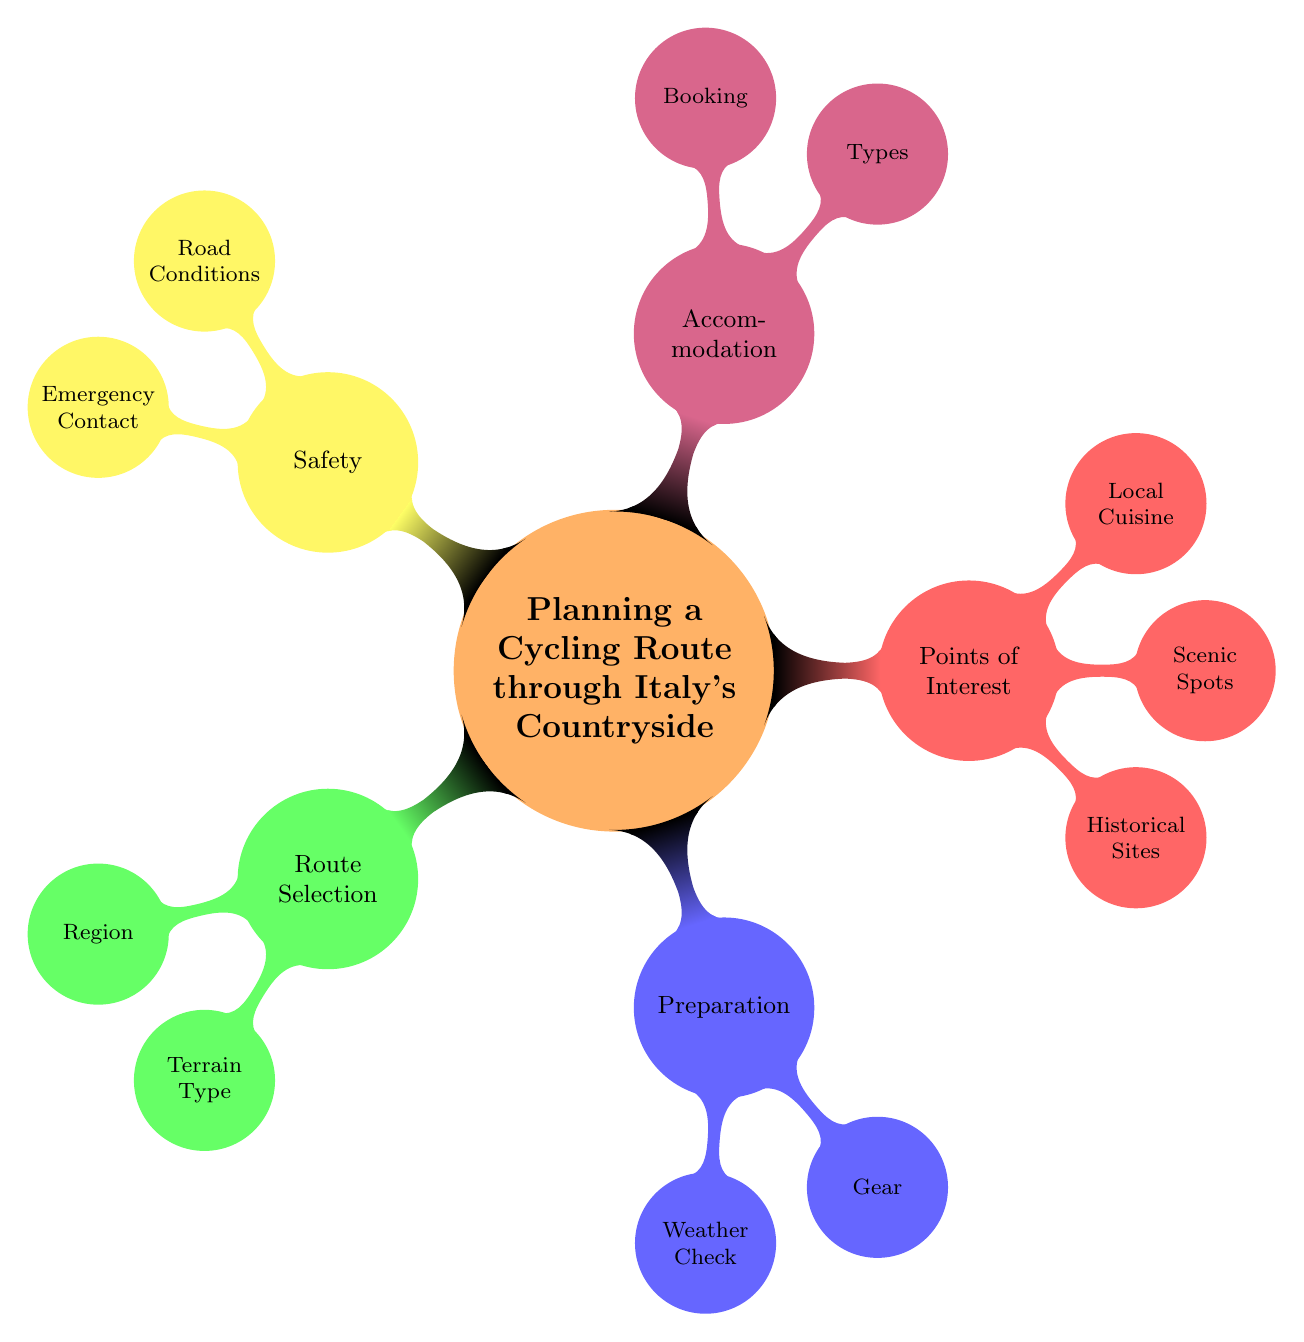What are the two main categories under Route Selection? The diagram lists "Region" and "Terrain Type" as the main categories under Route Selection. These are the child nodes connected to the Route Selection node, indicating the aspects to consider when selecting a route.
Answer: Region, Terrain Type How many points of interest categories are there? The Points of Interest section has three categories: Historical Sites, Scenic Spots, and Local Cuisine. The count is taken from the child nodes connected to the Points of Interest node.
Answer: 3 Which region is NOT listed under Route Selection? The regions mentioned under Route Selection are Tuscany, Umbria, Piedmont, and Emilia-Romagna. Since the question asks for a region not listed, we can assume "Lazio" or any other Italian region not mentioned.
Answer: Lazio What types of accommodation are included? The diagram indicates three types of accommodation: Agriturismo, B&B, and Historic Inns. These are directly connected as child nodes under the Accommodation section.
Answer: Agriturismo, B&B, Historic Inns Which safety aspect involves local healthcare? The safety aspect that involves local healthcare is "Emergency Contact". This node has child nodes that include local hospitals, bike repair shops, and police stations, all part of ensuring safety during the cycling trip.
Answer: Emergency Contact How does weather affect preparation? Weather Check is a preparation category that includes "Seasonal Conditions" and "Rain Forecasts". It indicates that understanding the weather is essential in preparing for a cycling route, affecting gear selection and travel plans.
Answer: Weather Check Which two aspects fall under Preparation? Under Preparation, the two aspects are "Weather Check" and "Gear". These are the primary considerations listed in the diagram to prepare for cycling in the countryside.
Answer: Weather Check, Gear What is one type of Local Cuisine venue? One type of Local Cuisine venue listed is "Wine Tasting Venues". This node indicates a specific point of interest for cyclists interested in experiencing local food and drink during their route.
Answer: Wine Tasting Venues 